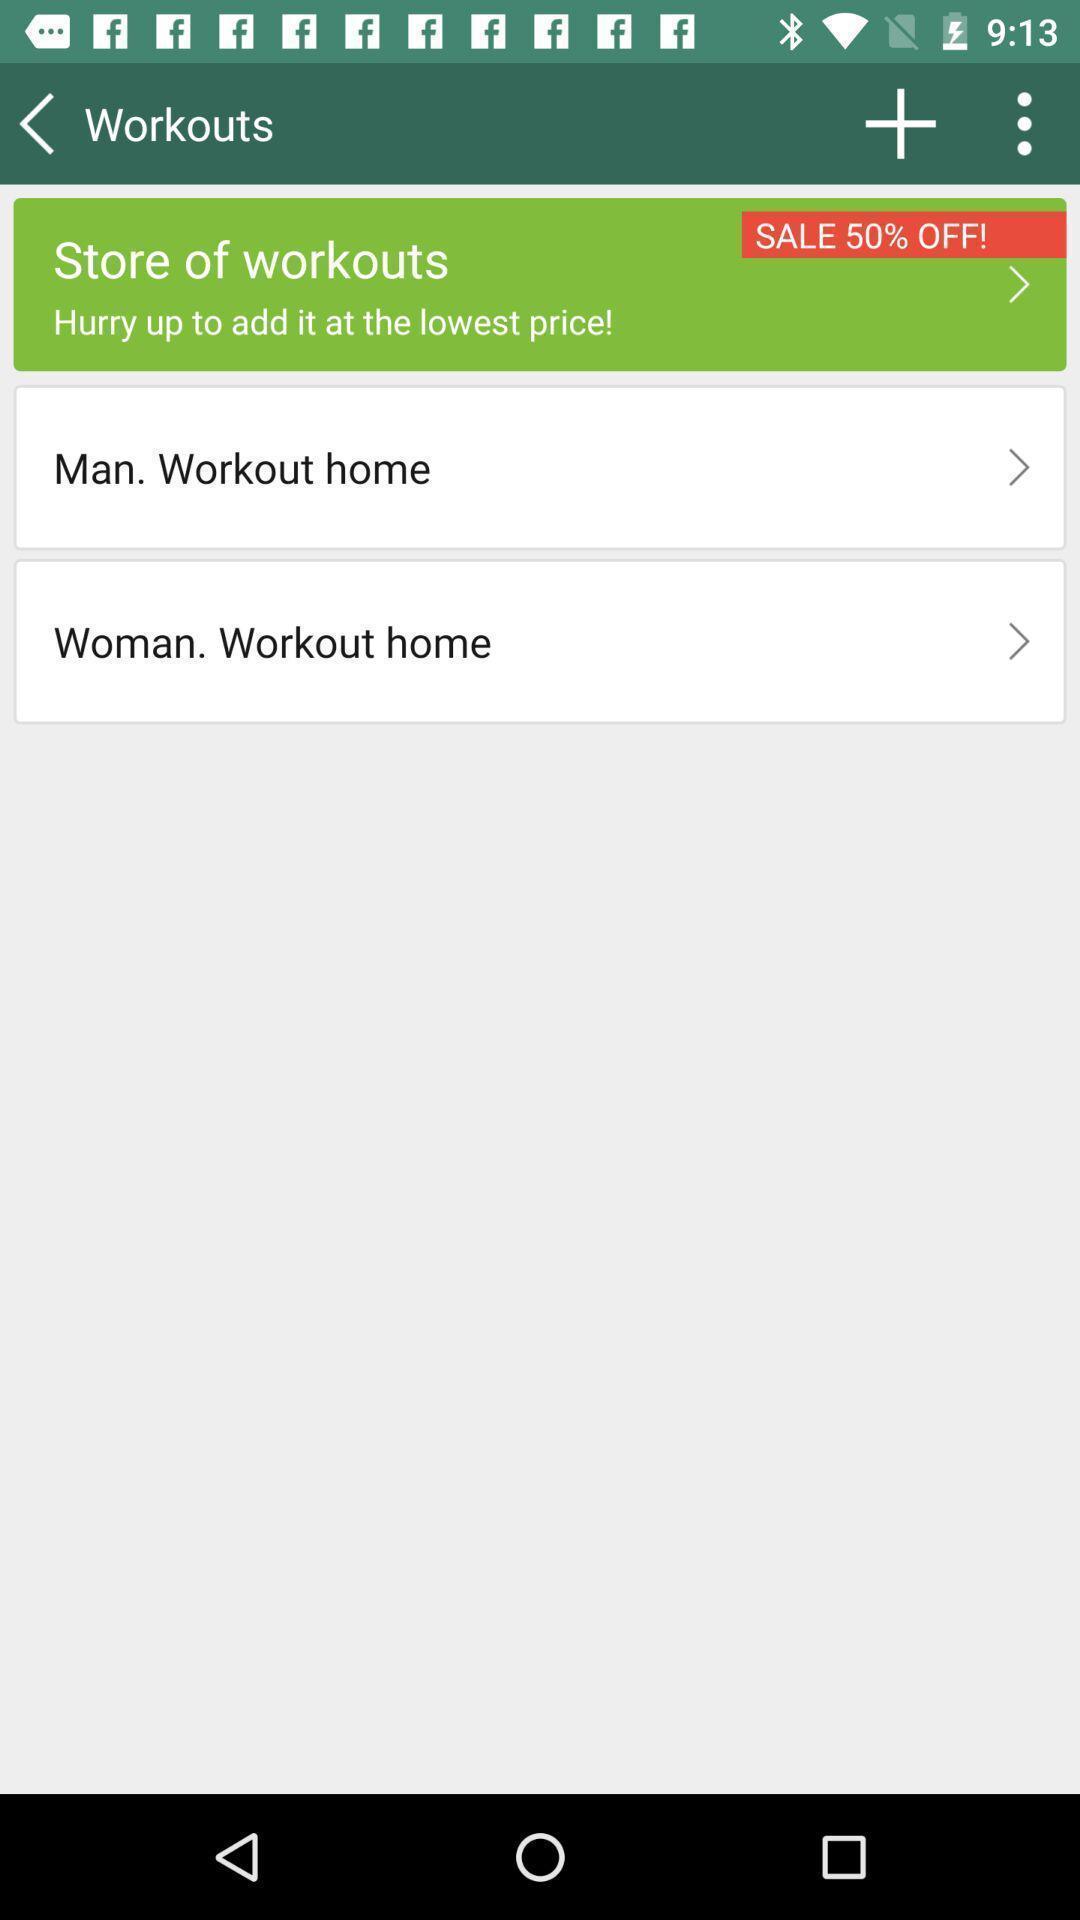Explain the elements present in this screenshot. Workouts page in a fitness app. 